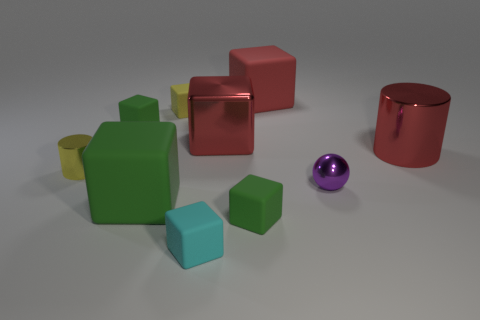The tiny thing that is both on the right side of the tiny cyan cube and in front of the big green block has what shape?
Keep it short and to the point. Cube. What color is the big rubber object to the left of the large red rubber cube?
Offer a terse response. Green. What is the size of the metal object that is both in front of the large metallic cylinder and behind the tiny purple object?
Ensure brevity in your answer.  Small. Are the ball and the tiny green thing that is in front of the tiny purple metal object made of the same material?
Offer a terse response. No. How many other matte things have the same shape as the small cyan matte thing?
Make the answer very short. 5. There is another cube that is the same color as the metal cube; what material is it?
Provide a short and direct response. Rubber. How many green blocks are there?
Your answer should be very brief. 3. Is the shape of the tiny yellow rubber object the same as the green rubber thing that is right of the yellow cube?
Your answer should be very brief. Yes. What number of things are either small blue matte cylinders or matte objects that are in front of the yellow cube?
Provide a succinct answer. 4. What is the material of the yellow object that is the same shape as the big green matte thing?
Keep it short and to the point. Rubber. 